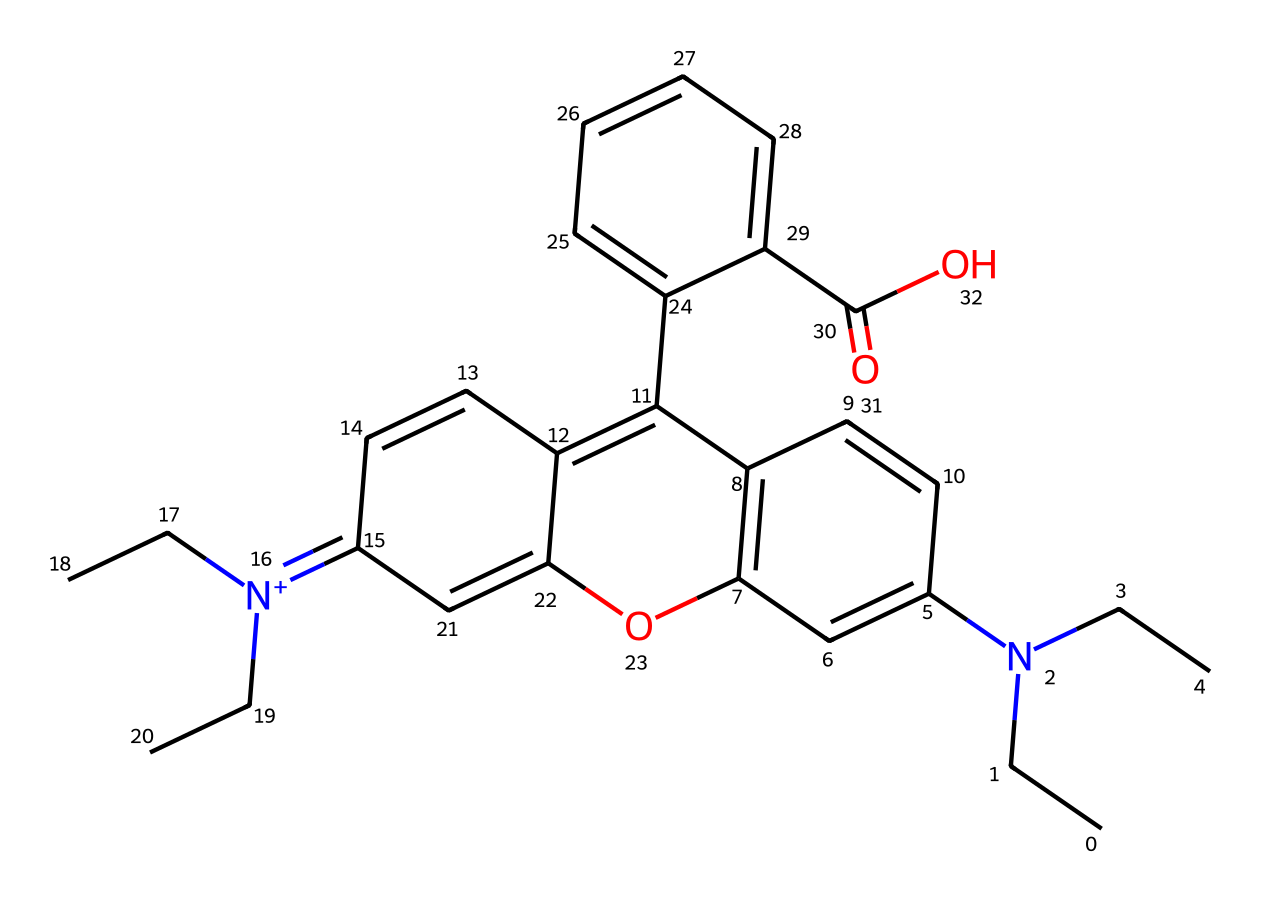What is the main functional group present in rhodamine B? The structure contains a hydroxyl group (-OH) and a carbonyl group (C=O), which indicates an alcohol or phenolic feature. However, the dominant functional group for its fluorescent properties is the xanthene core with nitrogen cationic contribution.
Answer: xanthene How many nitrogen atoms are present in rhodamine B's structure? By inspecting the SMILES representation, we identify the nitrogen atoms indicated by "N". There are two nitrogen atoms in rhodamine B.
Answer: two What is the molecular formula of rhodamine B? The SMILES is parsed to determine the number of each type of atom. The molecular formula calculated from the atom counts is C28H31ClN2O3.
Answer: C28H31ClN2O3 Which part of the rhodamine B structure contributes to its fluorescent properties? The xanthene core, characterized by its resonance structures and the presence of the nitrogen atoms, is primarily responsible for its fluorescence. This core allows for effective light absorption and emission.
Answer: xanthene core What type of dye is rhodamine B classified as? Given its characteristics and applications, rhodamine B is classified as a synthetic fluorescent dye. It has applications in fields like document security.
Answer: synthetic fluorescent dye 